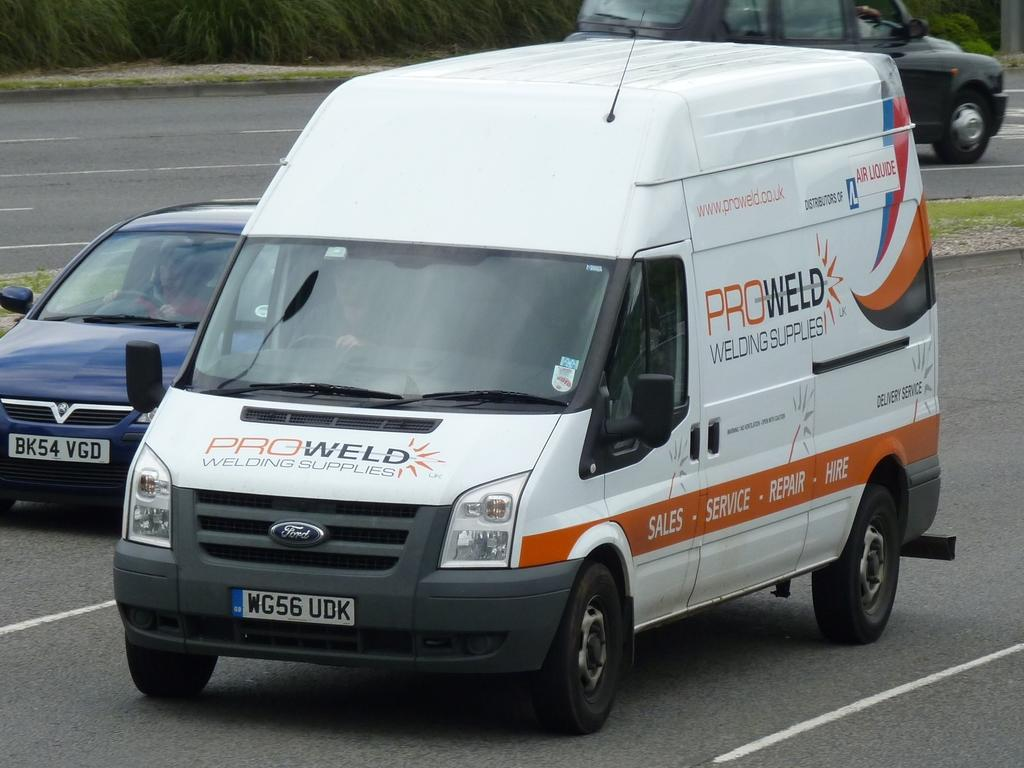<image>
Create a compact narrative representing the image presented. A Ford van with Pro Weld Welding Supplies on the side of it. 